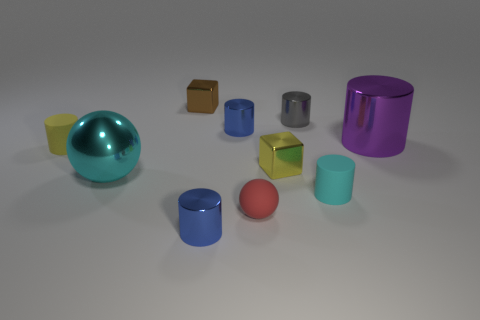What is the material of the small cylinder that is in front of the tiny yellow cylinder and to the left of the small yellow block?
Give a very brief answer. Metal. What number of metallic cylinders are the same size as the cyan rubber object?
Ensure brevity in your answer.  3. What color is the large object on the right side of the red ball that is on the right side of the large ball?
Keep it short and to the point. Purple. Is there a purple metal cylinder?
Keep it short and to the point. Yes. Is the purple thing the same shape as the brown metallic object?
Make the answer very short. No. There is a cylinder that is the same color as the metallic ball; what is its size?
Ensure brevity in your answer.  Small. There is a tiny blue thing in front of the cyan matte cylinder; how many red things are to the right of it?
Offer a terse response. 1. What number of things are behind the large cyan sphere and to the right of the small matte ball?
Your answer should be very brief. 3. What number of objects are tiny gray metal things or tiny blue cylinders behind the purple metallic cylinder?
Offer a terse response. 2. There is a yellow block that is made of the same material as the tiny gray cylinder; what is its size?
Provide a short and direct response. Small. 